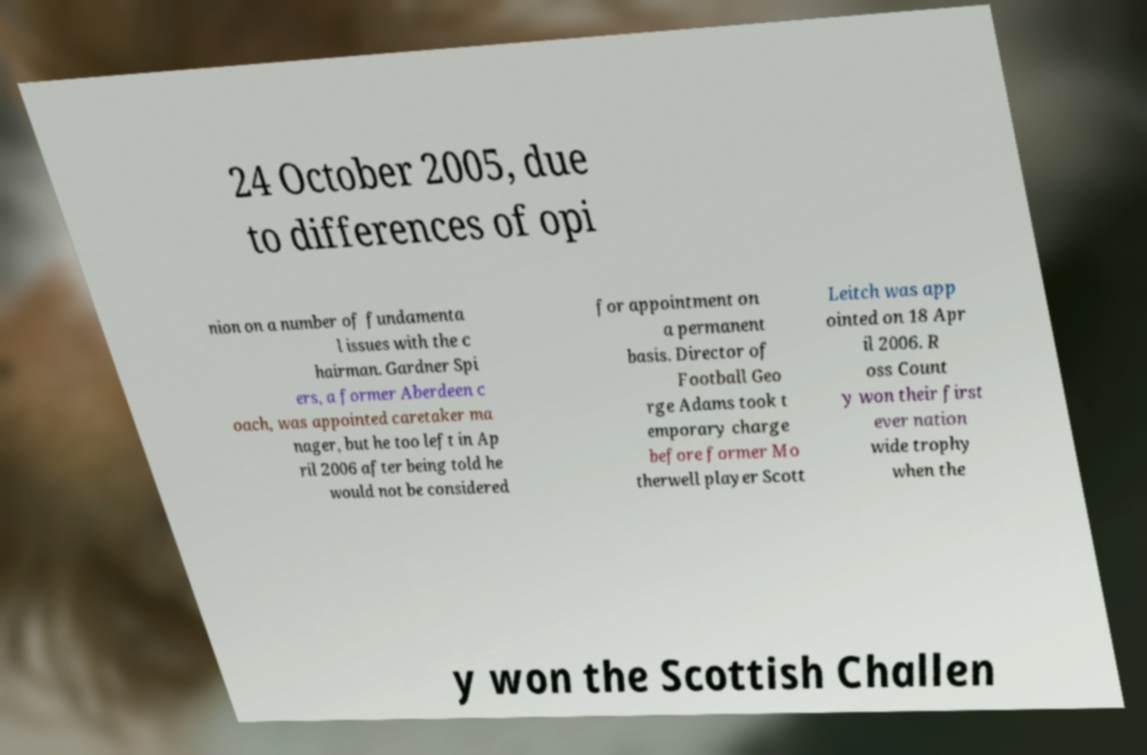Could you extract and type out the text from this image? 24 October 2005, due to differences of opi nion on a number of fundamenta l issues with the c hairman. Gardner Spi ers, a former Aberdeen c oach, was appointed caretaker ma nager, but he too left in Ap ril 2006 after being told he would not be considered for appointment on a permanent basis. Director of Football Geo rge Adams took t emporary charge before former Mo therwell player Scott Leitch was app ointed on 18 Apr il 2006. R oss Count y won their first ever nation wide trophy when the y won the Scottish Challen 